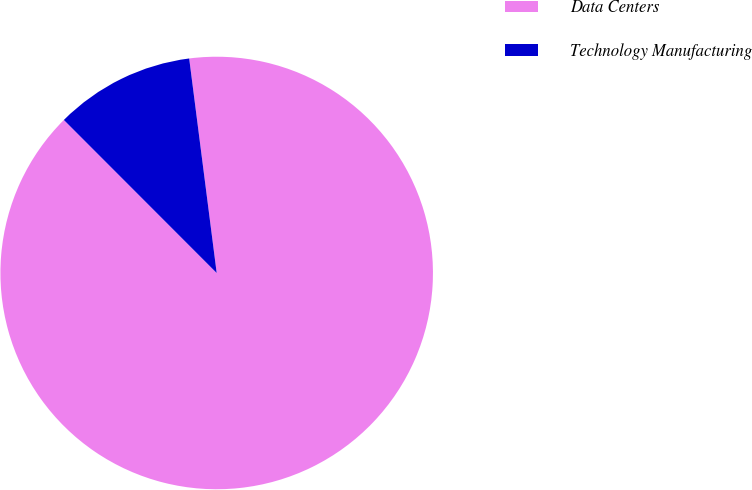Convert chart. <chart><loc_0><loc_0><loc_500><loc_500><pie_chart><fcel>Data Centers<fcel>Technology Manufacturing<nl><fcel>89.54%<fcel>10.46%<nl></chart> 